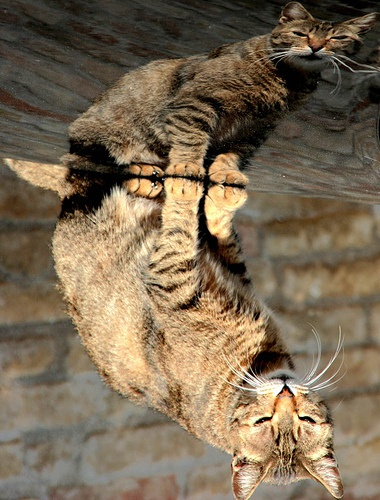Describe the objects in this image and their specific colors. I can see cat in black and tan tones and cat in black, gray, maroon, and tan tones in this image. 